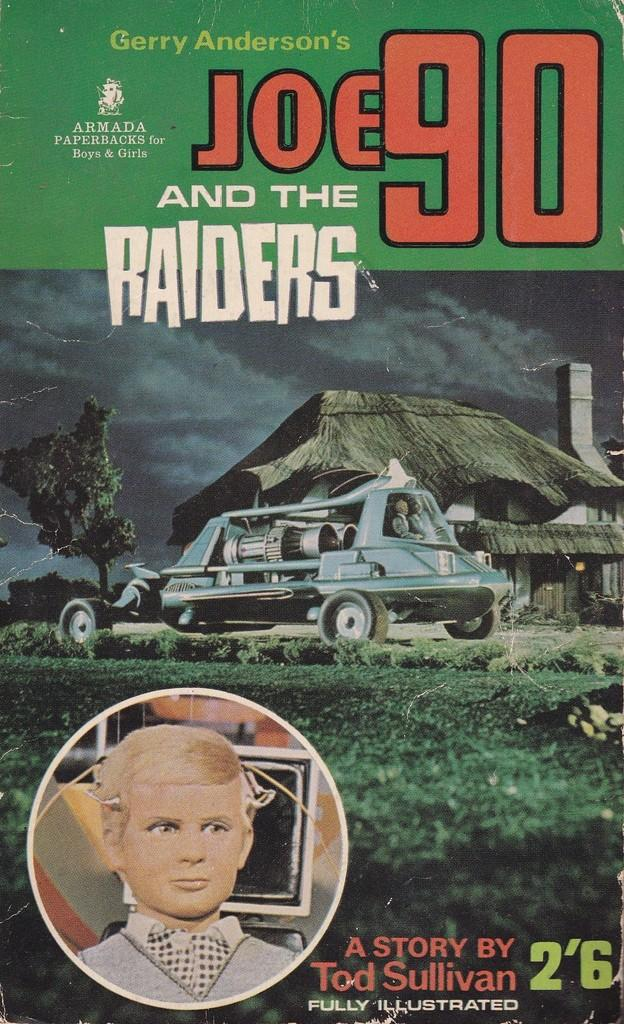What is present in the image that contains both text and images? There is a poster in the image that contains text and images. Where is the cannon located in the image? There is no cannon present in the image. What type of tooth is visible in the image? There is no tooth present in the image. 